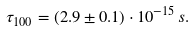Convert formula to latex. <formula><loc_0><loc_0><loc_500><loc_500>\tau _ { 1 0 0 } = ( 2 . 9 \pm 0 . 1 ) \cdot 1 0 ^ { - 1 5 } \, s .</formula> 